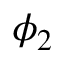Convert formula to latex. <formula><loc_0><loc_0><loc_500><loc_500>\phi _ { 2 }</formula> 